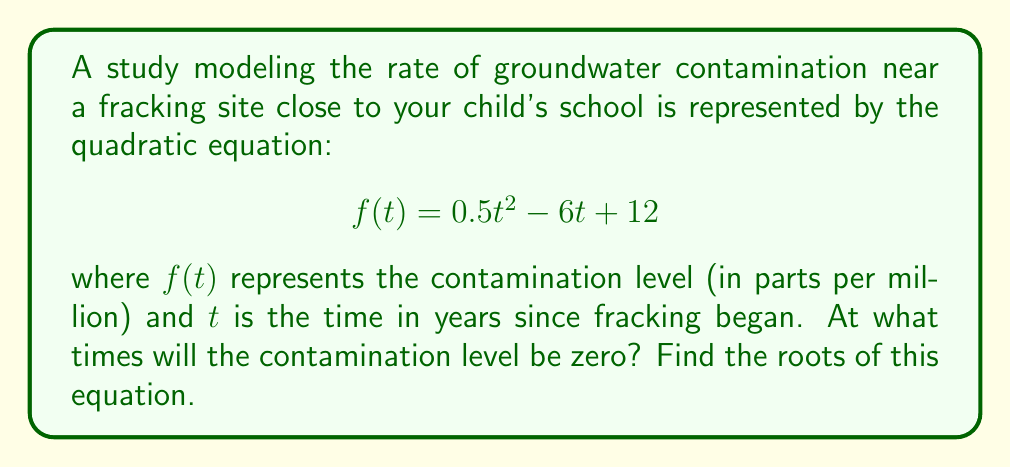Can you solve this math problem? To find the roots of this quadratic equation, we need to solve $f(t) = 0$. Let's use the quadratic formula:

For a quadratic equation in the form $ax^2 + bx + c = 0$, the roots are given by:

$$x = \frac{-b \pm \sqrt{b^2 - 4ac}}{2a}$$

In our equation $f(t) = 0.5t^2 - 6t + 12 = 0$, we have:

$a = 0.5$
$b = -6$
$c = 12$

Substituting these values into the quadratic formula:

$$t = \frac{-(-6) \pm \sqrt{(-6)^2 - 4(0.5)(12)}}{2(0.5)}$$

$$t = \frac{6 \pm \sqrt{36 - 24}}{1}$$

$$t = \frac{6 \pm \sqrt{12}}{1}$$

$$t = \frac{6 \pm 2\sqrt{3}}{1}$$

Therefore, the two roots are:

$$t_1 = 6 + 2\sqrt{3}$$
$$t_2 = 6 - 2\sqrt{3}$$

These roots represent the times (in years) when the contamination level will be zero.
Answer: The roots of the equation are $t_1 = 6 + 2\sqrt{3}$ years and $t_2 = 6 - 2\sqrt{3}$ years. 